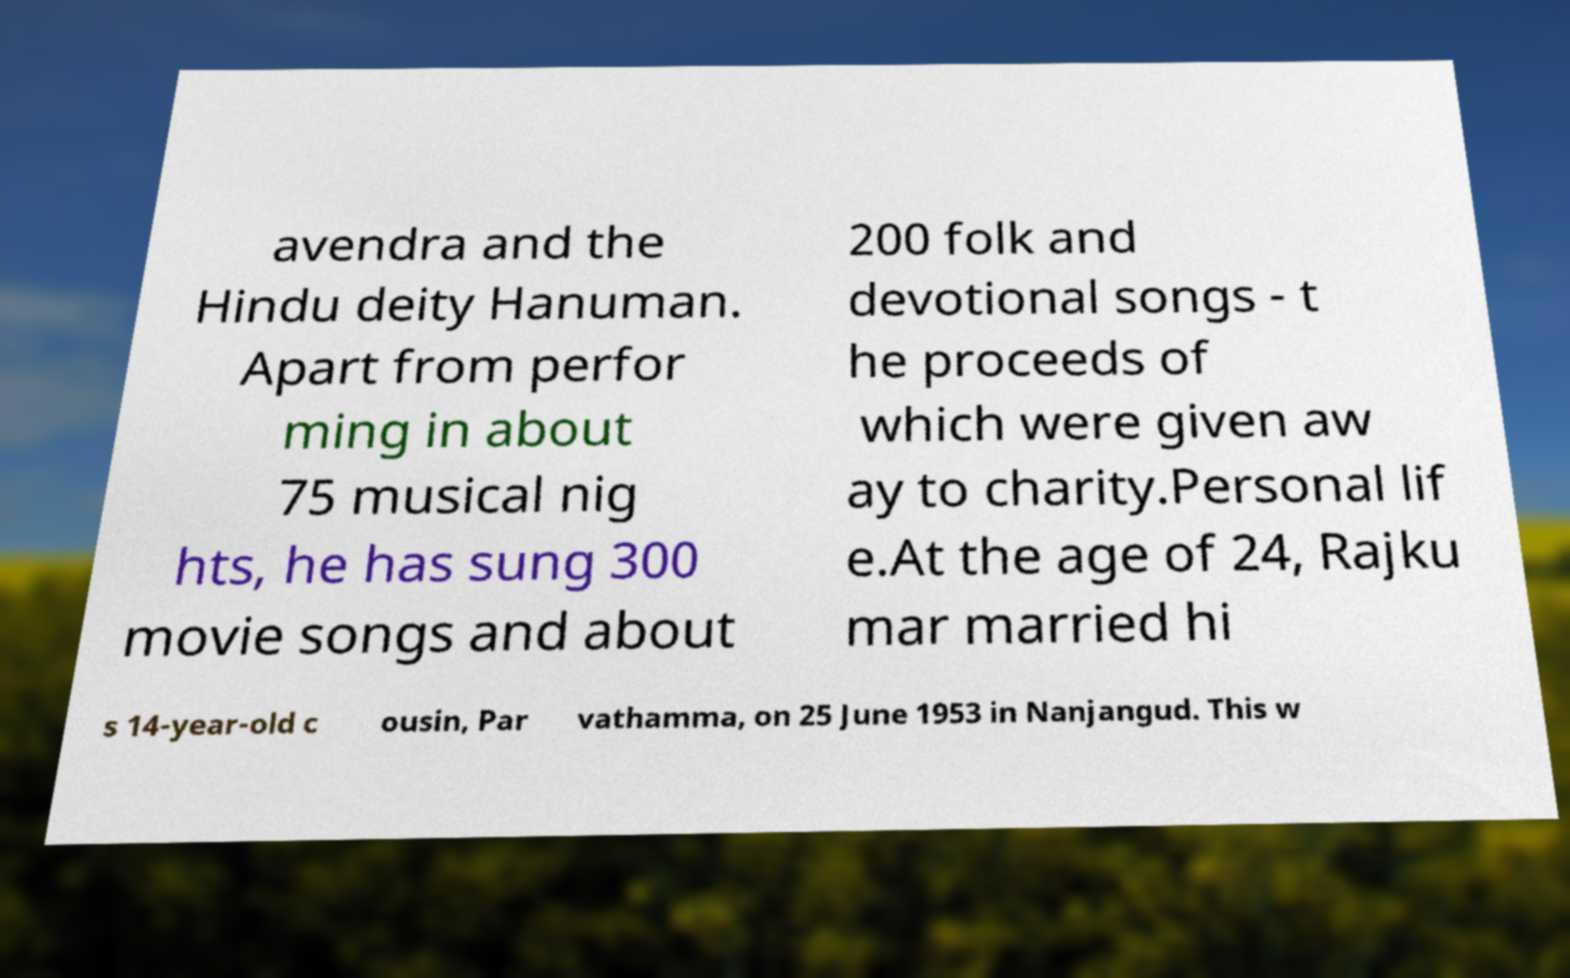Please read and relay the text visible in this image. What does it say? avendra and the Hindu deity Hanuman. Apart from perfor ming in about 75 musical nig hts, he has sung 300 movie songs and about 200 folk and devotional songs - t he proceeds of which were given aw ay to charity.Personal lif e.At the age of 24, Rajku mar married hi s 14-year-old c ousin, Par vathamma, on 25 June 1953 in Nanjangud. This w 